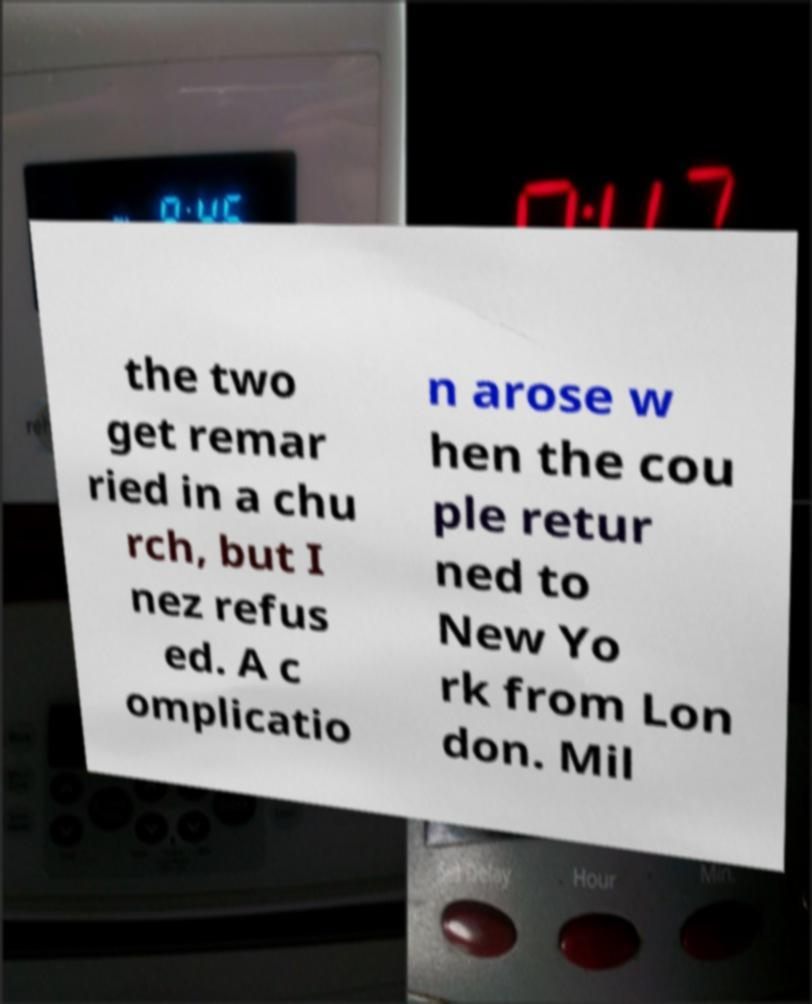Can you read and provide the text displayed in the image?This photo seems to have some interesting text. Can you extract and type it out for me? the two get remar ried in a chu rch, but I nez refus ed. A c omplicatio n arose w hen the cou ple retur ned to New Yo rk from Lon don. Mil 